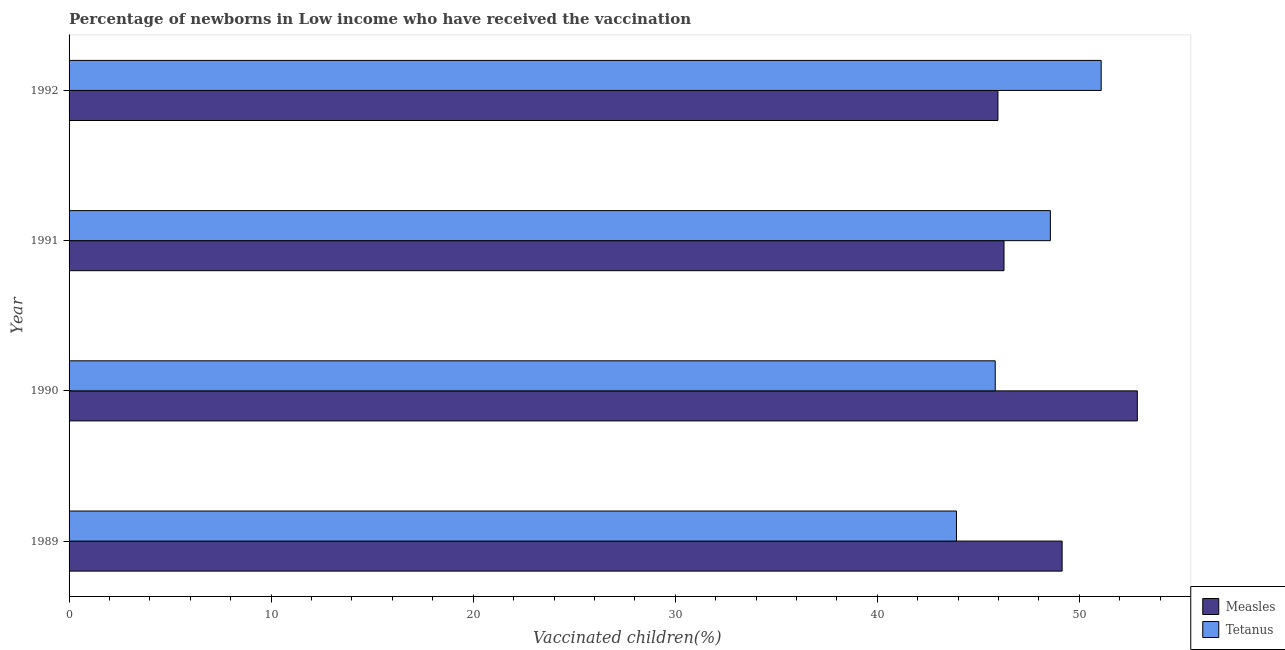How many groups of bars are there?
Provide a succinct answer. 4. Are the number of bars per tick equal to the number of legend labels?
Your answer should be very brief. Yes. What is the label of the 3rd group of bars from the top?
Give a very brief answer. 1990. In how many cases, is the number of bars for a given year not equal to the number of legend labels?
Your answer should be compact. 0. What is the percentage of newborns who received vaccination for tetanus in 1992?
Your response must be concise. 51.08. Across all years, what is the maximum percentage of newborns who received vaccination for measles?
Ensure brevity in your answer.  52.87. Across all years, what is the minimum percentage of newborns who received vaccination for measles?
Ensure brevity in your answer.  45.97. In which year was the percentage of newborns who received vaccination for tetanus maximum?
Offer a terse response. 1992. What is the total percentage of newborns who received vaccination for measles in the graph?
Give a very brief answer. 194.25. What is the difference between the percentage of newborns who received vaccination for measles in 1989 and that in 1992?
Your response must be concise. 3.18. What is the difference between the percentage of newborns who received vaccination for measles in 1991 and the percentage of newborns who received vaccination for tetanus in 1992?
Your answer should be very brief. -4.81. What is the average percentage of newborns who received vaccination for measles per year?
Your answer should be very brief. 48.56. In the year 1991, what is the difference between the percentage of newborns who received vaccination for measles and percentage of newborns who received vaccination for tetanus?
Give a very brief answer. -2.29. In how many years, is the percentage of newborns who received vaccination for tetanus greater than 36 %?
Give a very brief answer. 4. What is the ratio of the percentage of newborns who received vaccination for tetanus in 1991 to that in 1992?
Make the answer very short. 0.95. Is the percentage of newborns who received vaccination for tetanus in 1990 less than that in 1992?
Make the answer very short. Yes. What is the difference between the highest and the second highest percentage of newborns who received vaccination for tetanus?
Provide a short and direct response. 2.51. What is the difference between the highest and the lowest percentage of newborns who received vaccination for tetanus?
Provide a succinct answer. 7.16. In how many years, is the percentage of newborns who received vaccination for tetanus greater than the average percentage of newborns who received vaccination for tetanus taken over all years?
Your response must be concise. 2. What does the 1st bar from the top in 1991 represents?
Offer a very short reply. Tetanus. What does the 1st bar from the bottom in 1991 represents?
Provide a succinct answer. Measles. How many years are there in the graph?
Your response must be concise. 4. What is the difference between two consecutive major ticks on the X-axis?
Offer a very short reply. 10. Are the values on the major ticks of X-axis written in scientific E-notation?
Give a very brief answer. No. Does the graph contain any zero values?
Provide a short and direct response. No. Does the graph contain grids?
Give a very brief answer. No. Where does the legend appear in the graph?
Your answer should be very brief. Bottom right. How many legend labels are there?
Keep it short and to the point. 2. How are the legend labels stacked?
Offer a very short reply. Vertical. What is the title of the graph?
Offer a very short reply. Percentage of newborns in Low income who have received the vaccination. Does "Services" appear as one of the legend labels in the graph?
Your response must be concise. No. What is the label or title of the X-axis?
Your answer should be very brief. Vaccinated children(%)
. What is the Vaccinated children(%)
 in Measles in 1989?
Ensure brevity in your answer.  49.15. What is the Vaccinated children(%)
 of Tetanus in 1989?
Your response must be concise. 43.92. What is the Vaccinated children(%)
 of Measles in 1990?
Your answer should be compact. 52.87. What is the Vaccinated children(%)
 in Tetanus in 1990?
Ensure brevity in your answer.  45.84. What is the Vaccinated children(%)
 of Measles in 1991?
Offer a terse response. 46.27. What is the Vaccinated children(%)
 of Tetanus in 1991?
Keep it short and to the point. 48.57. What is the Vaccinated children(%)
 in Measles in 1992?
Keep it short and to the point. 45.97. What is the Vaccinated children(%)
 in Tetanus in 1992?
Offer a terse response. 51.08. Across all years, what is the maximum Vaccinated children(%)
 in Measles?
Offer a very short reply. 52.87. Across all years, what is the maximum Vaccinated children(%)
 in Tetanus?
Make the answer very short. 51.08. Across all years, what is the minimum Vaccinated children(%)
 in Measles?
Offer a very short reply. 45.97. Across all years, what is the minimum Vaccinated children(%)
 of Tetanus?
Your answer should be very brief. 43.92. What is the total Vaccinated children(%)
 of Measles in the graph?
Offer a very short reply. 194.25. What is the total Vaccinated children(%)
 of Tetanus in the graph?
Give a very brief answer. 189.4. What is the difference between the Vaccinated children(%)
 in Measles in 1989 and that in 1990?
Make the answer very short. -3.72. What is the difference between the Vaccinated children(%)
 in Tetanus in 1989 and that in 1990?
Your answer should be compact. -1.92. What is the difference between the Vaccinated children(%)
 in Measles in 1989 and that in 1991?
Your answer should be compact. 2.88. What is the difference between the Vaccinated children(%)
 of Tetanus in 1989 and that in 1991?
Offer a very short reply. -4.65. What is the difference between the Vaccinated children(%)
 in Measles in 1989 and that in 1992?
Make the answer very short. 3.18. What is the difference between the Vaccinated children(%)
 of Tetanus in 1989 and that in 1992?
Your answer should be compact. -7.16. What is the difference between the Vaccinated children(%)
 of Measles in 1990 and that in 1991?
Ensure brevity in your answer.  6.6. What is the difference between the Vaccinated children(%)
 of Tetanus in 1990 and that in 1991?
Provide a succinct answer. -2.73. What is the difference between the Vaccinated children(%)
 in Measles in 1990 and that in 1992?
Ensure brevity in your answer.  6.9. What is the difference between the Vaccinated children(%)
 of Tetanus in 1990 and that in 1992?
Keep it short and to the point. -5.24. What is the difference between the Vaccinated children(%)
 in Measles in 1991 and that in 1992?
Your answer should be very brief. 0.3. What is the difference between the Vaccinated children(%)
 of Tetanus in 1991 and that in 1992?
Provide a short and direct response. -2.51. What is the difference between the Vaccinated children(%)
 of Measles in 1989 and the Vaccinated children(%)
 of Tetanus in 1990?
Offer a terse response. 3.31. What is the difference between the Vaccinated children(%)
 in Measles in 1989 and the Vaccinated children(%)
 in Tetanus in 1991?
Provide a succinct answer. 0.58. What is the difference between the Vaccinated children(%)
 of Measles in 1989 and the Vaccinated children(%)
 of Tetanus in 1992?
Offer a very short reply. -1.93. What is the difference between the Vaccinated children(%)
 of Measles in 1990 and the Vaccinated children(%)
 of Tetanus in 1991?
Offer a very short reply. 4.3. What is the difference between the Vaccinated children(%)
 in Measles in 1990 and the Vaccinated children(%)
 in Tetanus in 1992?
Offer a very short reply. 1.79. What is the difference between the Vaccinated children(%)
 in Measles in 1991 and the Vaccinated children(%)
 in Tetanus in 1992?
Provide a short and direct response. -4.81. What is the average Vaccinated children(%)
 of Measles per year?
Keep it short and to the point. 48.56. What is the average Vaccinated children(%)
 of Tetanus per year?
Provide a succinct answer. 47.35. In the year 1989, what is the difference between the Vaccinated children(%)
 of Measles and Vaccinated children(%)
 of Tetanus?
Your response must be concise. 5.23. In the year 1990, what is the difference between the Vaccinated children(%)
 in Measles and Vaccinated children(%)
 in Tetanus?
Ensure brevity in your answer.  7.03. In the year 1991, what is the difference between the Vaccinated children(%)
 in Measles and Vaccinated children(%)
 in Tetanus?
Ensure brevity in your answer.  -2.3. In the year 1992, what is the difference between the Vaccinated children(%)
 in Measles and Vaccinated children(%)
 in Tetanus?
Make the answer very short. -5.11. What is the ratio of the Vaccinated children(%)
 in Measles in 1989 to that in 1990?
Your answer should be very brief. 0.93. What is the ratio of the Vaccinated children(%)
 in Tetanus in 1989 to that in 1990?
Provide a short and direct response. 0.96. What is the ratio of the Vaccinated children(%)
 of Measles in 1989 to that in 1991?
Keep it short and to the point. 1.06. What is the ratio of the Vaccinated children(%)
 of Tetanus in 1989 to that in 1991?
Provide a short and direct response. 0.9. What is the ratio of the Vaccinated children(%)
 of Measles in 1989 to that in 1992?
Offer a very short reply. 1.07. What is the ratio of the Vaccinated children(%)
 in Tetanus in 1989 to that in 1992?
Provide a succinct answer. 0.86. What is the ratio of the Vaccinated children(%)
 in Measles in 1990 to that in 1991?
Your answer should be compact. 1.14. What is the ratio of the Vaccinated children(%)
 in Tetanus in 1990 to that in 1991?
Make the answer very short. 0.94. What is the ratio of the Vaccinated children(%)
 of Measles in 1990 to that in 1992?
Ensure brevity in your answer.  1.15. What is the ratio of the Vaccinated children(%)
 in Tetanus in 1990 to that in 1992?
Provide a short and direct response. 0.9. What is the ratio of the Vaccinated children(%)
 in Measles in 1991 to that in 1992?
Offer a terse response. 1.01. What is the ratio of the Vaccinated children(%)
 of Tetanus in 1991 to that in 1992?
Keep it short and to the point. 0.95. What is the difference between the highest and the second highest Vaccinated children(%)
 in Measles?
Your response must be concise. 3.72. What is the difference between the highest and the second highest Vaccinated children(%)
 of Tetanus?
Make the answer very short. 2.51. What is the difference between the highest and the lowest Vaccinated children(%)
 in Measles?
Your answer should be compact. 6.9. What is the difference between the highest and the lowest Vaccinated children(%)
 in Tetanus?
Provide a short and direct response. 7.16. 